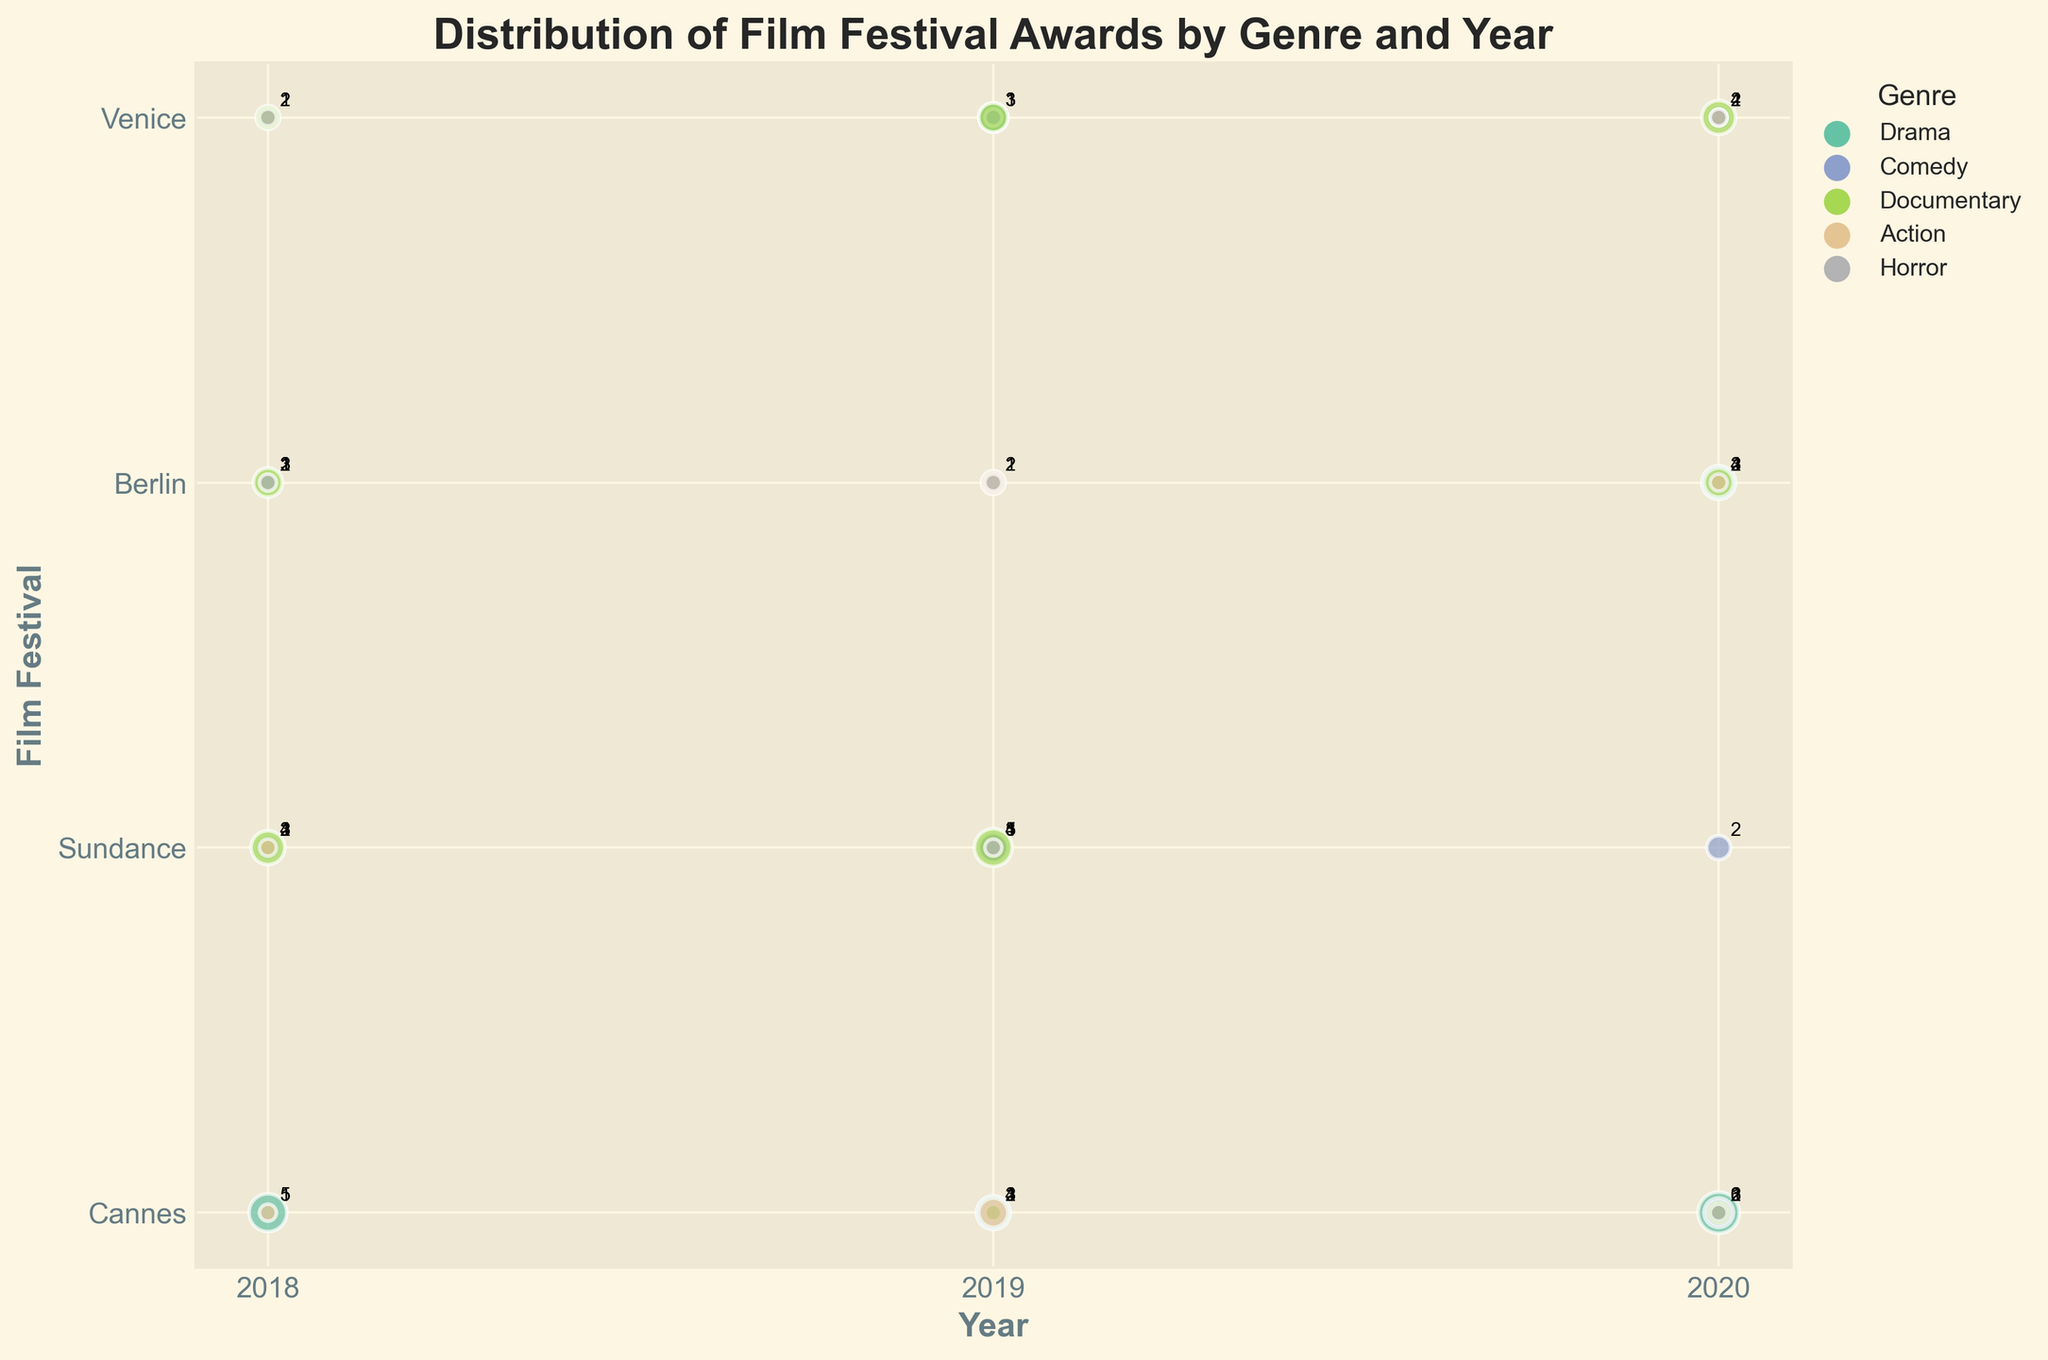What is the title of the bubble chart? The title of the bubble chart is displayed at the top of the figure. It is usually in bold and larger font size compared to other text.
Answer: Distribution of Film Festival Awards by Genre and Year What are the labels for the x-axis and y-axis? The labels for axes are usually displayed adjacent to the axes. The x-axis label is below the horizontal axis, and the y-axis label is beside the vertical axis.
Answer: Year, Film Festival What year has the genre Drama won the most awards at Cannes? Find the largest bubble along the horizontal axis (Year) for Drama at Cannes. The legend will help identify the color representing Drama.
Answer: 2020 How many awards did Comedy win at Sundance in 2019? Locate the bubble for Comedy at Sundance in 2019 by first identifying the genre through color and then the year. The size/value is usually annotated near the bubble.
Answer: 3 Which genre had the smallest bubble in 2018, and which film festival does it correspond to? Find the smallest bubble for 2018 by comparing sizes and cross-checking the corresponding genres and film festivals through bubble annotation or position.
Answer: Action, Berlin In which genre and year did the Berlin Film Festival record the highest awards? Identify the largest bubble corresponding to the Berlin Film Festival by comparing bubble sizes and cross-referencing genres and years from the annotations.
Answer: Drama, 2020 Compare the number of awards won by Documentary at Venice across 2018, 2019, and 2020. Which year had the highest total? Check the bubble sizes for Documentary at Venice for 2018, 2019, and 2020, and note the annotated number of awards. Sum the awards for each year.
Answer: 2020 How does the number of Drama awards in 2020 at Venice compare to Comedy awards in 2020 at Cannes? Locate the bubbles for Drama at Venice and Comedy at Cannes in 2020. Compare their sizes or annotations to determine the number of awards.
Answer: Drama has fewer awards Which genre has a constant number of awards at the Berlin Film Festival over the years? Identify the genre with bubbles at the Berlin Film Festival that have the same size/annotation across different years by comparing their values.
Answer: Horror What is the total number of awards won by Horror across all film festivals and years? Locate all bubbles corresponding to Horror across the entire figure. Sum the values annotated near each bubble.
Answer: 5 